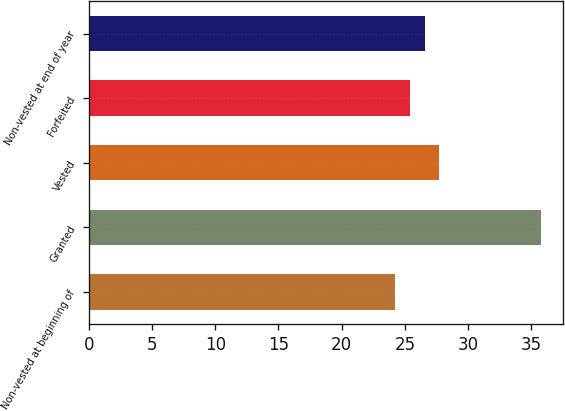Convert chart. <chart><loc_0><loc_0><loc_500><loc_500><bar_chart><fcel>Non-vested at beginning of<fcel>Granted<fcel>Vested<fcel>Forfeited<fcel>Non-vested at end of year<nl><fcel>24.26<fcel>35.74<fcel>27.74<fcel>25.41<fcel>26.59<nl></chart> 